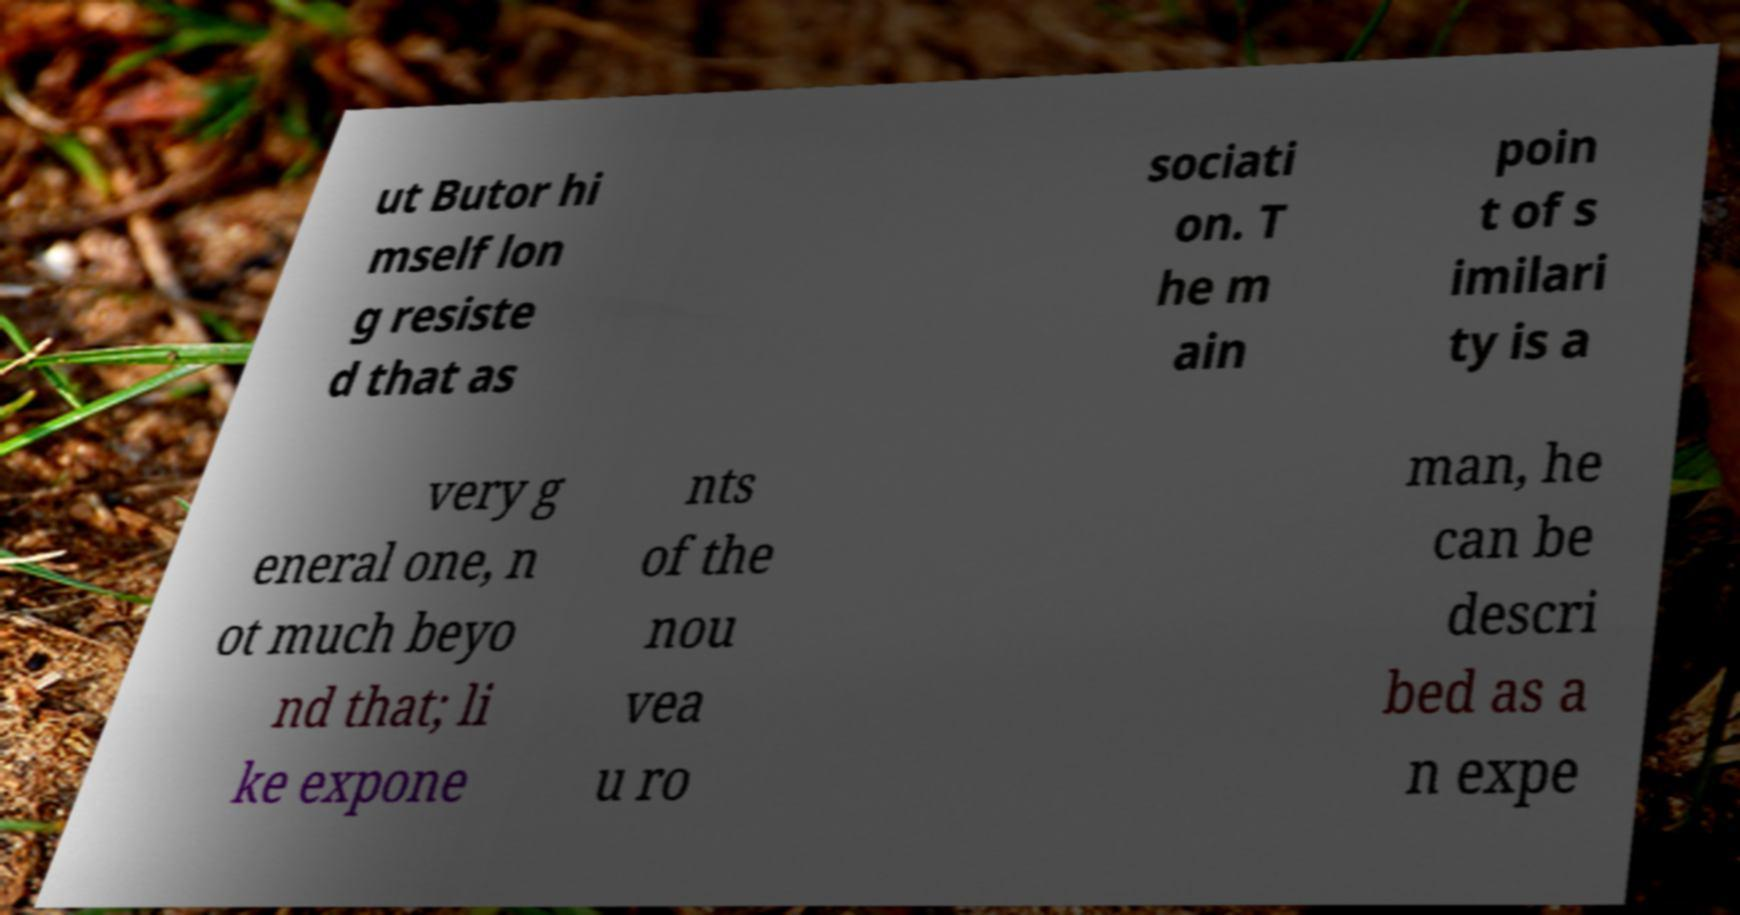What messages or text are displayed in this image? I need them in a readable, typed format. ut Butor hi mself lon g resiste d that as sociati on. T he m ain poin t of s imilari ty is a very g eneral one, n ot much beyo nd that; li ke expone nts of the nou vea u ro man, he can be descri bed as a n expe 